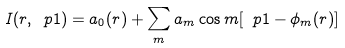<formula> <loc_0><loc_0><loc_500><loc_500>I ( r , \ p 1 ) = a _ { 0 } ( r ) + \sum _ { m } a _ { m } \cos m [ \ p 1 - \phi _ { m } ( r ) ]</formula> 